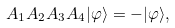<formula> <loc_0><loc_0><loc_500><loc_500>A _ { 1 } A _ { 2 } A _ { 3 } A _ { 4 } | \varphi \rangle = - | \varphi \rangle ,</formula> 